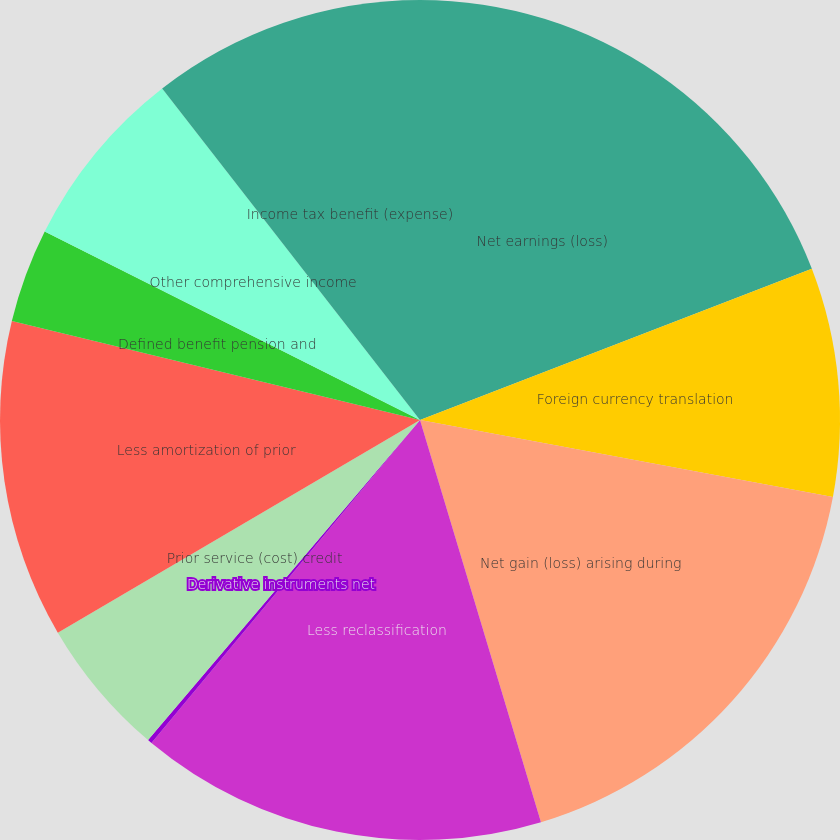Convert chart. <chart><loc_0><loc_0><loc_500><loc_500><pie_chart><fcel>Net earnings (loss)<fcel>Foreign currency translation<fcel>Net gain (loss) arising during<fcel>Less reclassification<fcel>Derivative instruments net<fcel>Prior service (cost) credit<fcel>Less amortization of prior<fcel>Defined benefit pension and<fcel>Other comprehensive income<fcel>Income tax benefit (expense)<nl><fcel>19.14%<fcel>8.79%<fcel>17.42%<fcel>15.69%<fcel>0.17%<fcel>5.34%<fcel>12.24%<fcel>3.62%<fcel>7.07%<fcel>10.52%<nl></chart> 